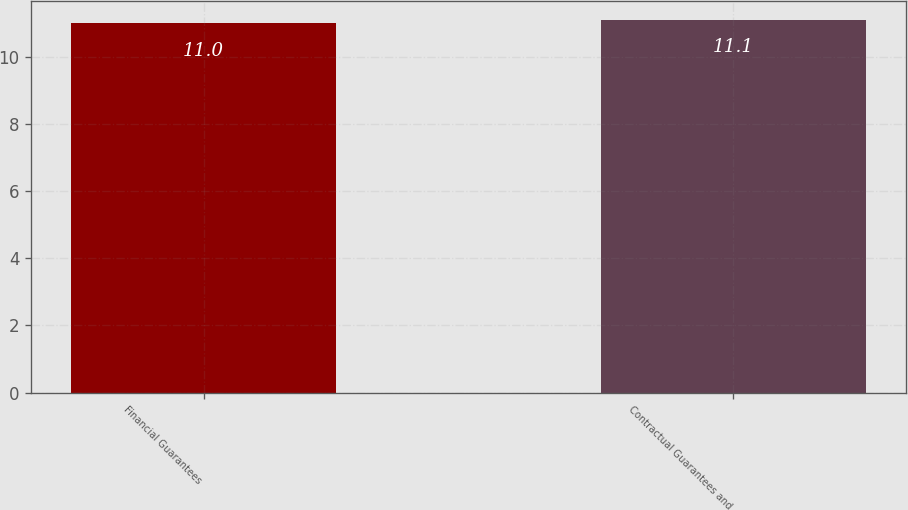<chart> <loc_0><loc_0><loc_500><loc_500><bar_chart><fcel>Financial Guarantees<fcel>Contractual Guarantees and<nl><fcel>11<fcel>11.1<nl></chart> 